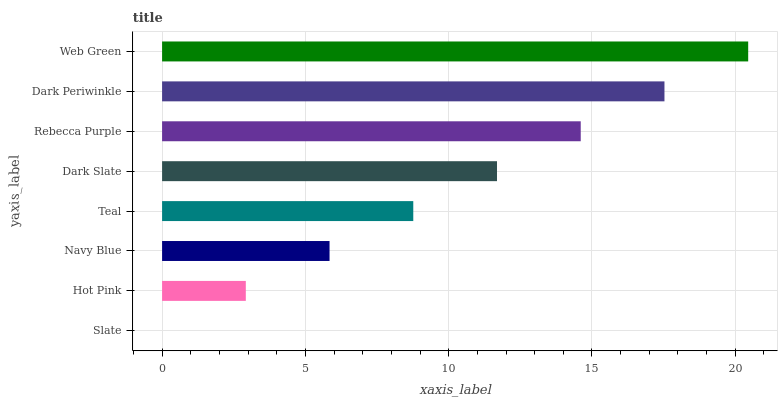Is Slate the minimum?
Answer yes or no. Yes. Is Web Green the maximum?
Answer yes or no. Yes. Is Hot Pink the minimum?
Answer yes or no. No. Is Hot Pink the maximum?
Answer yes or no. No. Is Hot Pink greater than Slate?
Answer yes or no. Yes. Is Slate less than Hot Pink?
Answer yes or no. Yes. Is Slate greater than Hot Pink?
Answer yes or no. No. Is Hot Pink less than Slate?
Answer yes or no. No. Is Dark Slate the high median?
Answer yes or no. Yes. Is Teal the low median?
Answer yes or no. Yes. Is Slate the high median?
Answer yes or no. No. Is Rebecca Purple the low median?
Answer yes or no. No. 